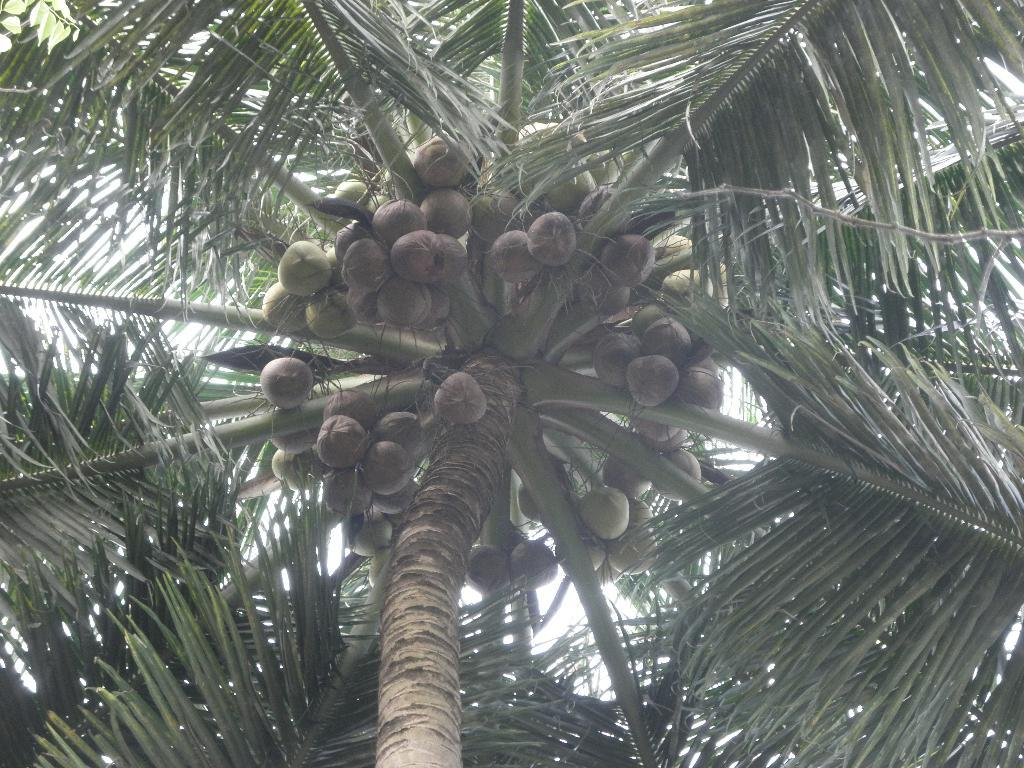What type of tree is in the image? There is a coconut tree in the image. What colors can be seen on the coconut tree? The coconut tree is green and brown in color. What is hanging from the tree? There are coconuts on the tree. What colors can be seen on the coconuts? The coconuts are brown and green in color. What is visible in the background of the image? The sky is visible in the background of the image. How many pins are attached to the coconuts in the image? There are no pins present in the image; it only features a coconut tree with coconuts. 